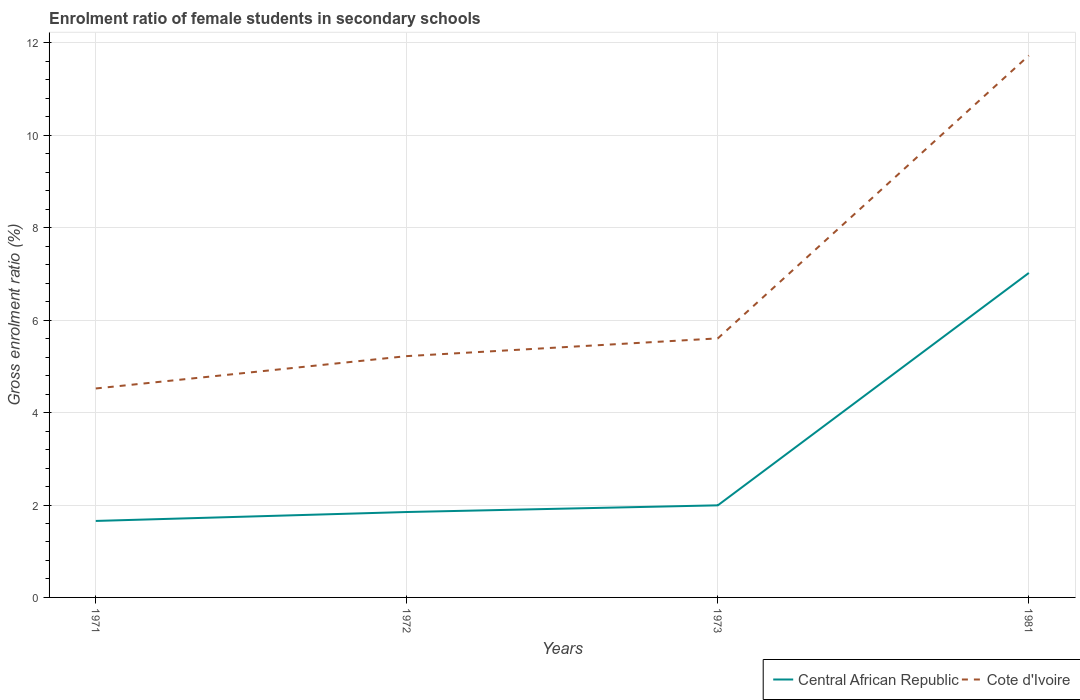How many different coloured lines are there?
Your answer should be compact. 2. Is the number of lines equal to the number of legend labels?
Your response must be concise. Yes. Across all years, what is the maximum enrolment ratio of female students in secondary schools in Central African Republic?
Provide a succinct answer. 1.66. In which year was the enrolment ratio of female students in secondary schools in Central African Republic maximum?
Your answer should be compact. 1971. What is the total enrolment ratio of female students in secondary schools in Cote d'Ivoire in the graph?
Provide a succinct answer. -6.5. What is the difference between the highest and the second highest enrolment ratio of female students in secondary schools in Cote d'Ivoire?
Your answer should be very brief. 7.21. What is the difference between the highest and the lowest enrolment ratio of female students in secondary schools in Central African Republic?
Provide a short and direct response. 1. How many lines are there?
Offer a very short reply. 2. How many years are there in the graph?
Offer a very short reply. 4. Where does the legend appear in the graph?
Your answer should be compact. Bottom right. What is the title of the graph?
Your response must be concise. Enrolment ratio of female students in secondary schools. What is the label or title of the X-axis?
Keep it short and to the point. Years. What is the Gross enrolment ratio (%) in Central African Republic in 1971?
Your answer should be very brief. 1.66. What is the Gross enrolment ratio (%) in Cote d'Ivoire in 1971?
Your answer should be compact. 4.52. What is the Gross enrolment ratio (%) in Central African Republic in 1972?
Your answer should be compact. 1.85. What is the Gross enrolment ratio (%) of Cote d'Ivoire in 1972?
Provide a short and direct response. 5.22. What is the Gross enrolment ratio (%) in Central African Republic in 1973?
Provide a short and direct response. 1.99. What is the Gross enrolment ratio (%) in Cote d'Ivoire in 1973?
Offer a terse response. 5.61. What is the Gross enrolment ratio (%) in Central African Republic in 1981?
Give a very brief answer. 7.02. What is the Gross enrolment ratio (%) in Cote d'Ivoire in 1981?
Ensure brevity in your answer.  11.73. Across all years, what is the maximum Gross enrolment ratio (%) in Central African Republic?
Ensure brevity in your answer.  7.02. Across all years, what is the maximum Gross enrolment ratio (%) in Cote d'Ivoire?
Your response must be concise. 11.73. Across all years, what is the minimum Gross enrolment ratio (%) in Central African Republic?
Your response must be concise. 1.66. Across all years, what is the minimum Gross enrolment ratio (%) in Cote d'Ivoire?
Make the answer very short. 4.52. What is the total Gross enrolment ratio (%) of Central African Republic in the graph?
Offer a terse response. 12.52. What is the total Gross enrolment ratio (%) of Cote d'Ivoire in the graph?
Your answer should be compact. 27.08. What is the difference between the Gross enrolment ratio (%) in Central African Republic in 1971 and that in 1972?
Provide a short and direct response. -0.19. What is the difference between the Gross enrolment ratio (%) of Cote d'Ivoire in 1971 and that in 1972?
Offer a terse response. -0.7. What is the difference between the Gross enrolment ratio (%) of Central African Republic in 1971 and that in 1973?
Offer a terse response. -0.34. What is the difference between the Gross enrolment ratio (%) in Cote d'Ivoire in 1971 and that in 1973?
Provide a short and direct response. -1.08. What is the difference between the Gross enrolment ratio (%) of Central African Republic in 1971 and that in 1981?
Give a very brief answer. -5.37. What is the difference between the Gross enrolment ratio (%) in Cote d'Ivoire in 1971 and that in 1981?
Offer a very short reply. -7.21. What is the difference between the Gross enrolment ratio (%) in Central African Republic in 1972 and that in 1973?
Offer a very short reply. -0.14. What is the difference between the Gross enrolment ratio (%) of Cote d'Ivoire in 1972 and that in 1973?
Your response must be concise. -0.38. What is the difference between the Gross enrolment ratio (%) of Central African Republic in 1972 and that in 1981?
Give a very brief answer. -5.17. What is the difference between the Gross enrolment ratio (%) of Cote d'Ivoire in 1972 and that in 1981?
Provide a succinct answer. -6.5. What is the difference between the Gross enrolment ratio (%) of Central African Republic in 1973 and that in 1981?
Your response must be concise. -5.03. What is the difference between the Gross enrolment ratio (%) of Cote d'Ivoire in 1973 and that in 1981?
Ensure brevity in your answer.  -6.12. What is the difference between the Gross enrolment ratio (%) in Central African Republic in 1971 and the Gross enrolment ratio (%) in Cote d'Ivoire in 1972?
Ensure brevity in your answer.  -3.57. What is the difference between the Gross enrolment ratio (%) of Central African Republic in 1971 and the Gross enrolment ratio (%) of Cote d'Ivoire in 1973?
Your answer should be compact. -3.95. What is the difference between the Gross enrolment ratio (%) in Central African Republic in 1971 and the Gross enrolment ratio (%) in Cote d'Ivoire in 1981?
Offer a very short reply. -10.07. What is the difference between the Gross enrolment ratio (%) in Central African Republic in 1972 and the Gross enrolment ratio (%) in Cote d'Ivoire in 1973?
Keep it short and to the point. -3.76. What is the difference between the Gross enrolment ratio (%) of Central African Republic in 1972 and the Gross enrolment ratio (%) of Cote d'Ivoire in 1981?
Offer a terse response. -9.88. What is the difference between the Gross enrolment ratio (%) in Central African Republic in 1973 and the Gross enrolment ratio (%) in Cote d'Ivoire in 1981?
Your answer should be compact. -9.73. What is the average Gross enrolment ratio (%) of Central African Republic per year?
Your response must be concise. 3.13. What is the average Gross enrolment ratio (%) of Cote d'Ivoire per year?
Your response must be concise. 6.77. In the year 1971, what is the difference between the Gross enrolment ratio (%) of Central African Republic and Gross enrolment ratio (%) of Cote d'Ivoire?
Offer a very short reply. -2.87. In the year 1972, what is the difference between the Gross enrolment ratio (%) in Central African Republic and Gross enrolment ratio (%) in Cote d'Ivoire?
Your response must be concise. -3.37. In the year 1973, what is the difference between the Gross enrolment ratio (%) in Central African Republic and Gross enrolment ratio (%) in Cote d'Ivoire?
Your answer should be very brief. -3.61. In the year 1981, what is the difference between the Gross enrolment ratio (%) of Central African Republic and Gross enrolment ratio (%) of Cote d'Ivoire?
Offer a terse response. -4.71. What is the ratio of the Gross enrolment ratio (%) of Central African Republic in 1971 to that in 1972?
Your answer should be very brief. 0.9. What is the ratio of the Gross enrolment ratio (%) in Cote d'Ivoire in 1971 to that in 1972?
Offer a very short reply. 0.87. What is the ratio of the Gross enrolment ratio (%) of Central African Republic in 1971 to that in 1973?
Make the answer very short. 0.83. What is the ratio of the Gross enrolment ratio (%) of Cote d'Ivoire in 1971 to that in 1973?
Ensure brevity in your answer.  0.81. What is the ratio of the Gross enrolment ratio (%) of Central African Republic in 1971 to that in 1981?
Provide a short and direct response. 0.24. What is the ratio of the Gross enrolment ratio (%) of Cote d'Ivoire in 1971 to that in 1981?
Keep it short and to the point. 0.39. What is the ratio of the Gross enrolment ratio (%) of Central African Republic in 1972 to that in 1973?
Keep it short and to the point. 0.93. What is the ratio of the Gross enrolment ratio (%) in Cote d'Ivoire in 1972 to that in 1973?
Your answer should be very brief. 0.93. What is the ratio of the Gross enrolment ratio (%) of Central African Republic in 1972 to that in 1981?
Offer a very short reply. 0.26. What is the ratio of the Gross enrolment ratio (%) in Cote d'Ivoire in 1972 to that in 1981?
Give a very brief answer. 0.45. What is the ratio of the Gross enrolment ratio (%) of Central African Republic in 1973 to that in 1981?
Your answer should be very brief. 0.28. What is the ratio of the Gross enrolment ratio (%) in Cote d'Ivoire in 1973 to that in 1981?
Make the answer very short. 0.48. What is the difference between the highest and the second highest Gross enrolment ratio (%) of Central African Republic?
Keep it short and to the point. 5.03. What is the difference between the highest and the second highest Gross enrolment ratio (%) in Cote d'Ivoire?
Your response must be concise. 6.12. What is the difference between the highest and the lowest Gross enrolment ratio (%) of Central African Republic?
Provide a short and direct response. 5.37. What is the difference between the highest and the lowest Gross enrolment ratio (%) in Cote d'Ivoire?
Provide a succinct answer. 7.21. 